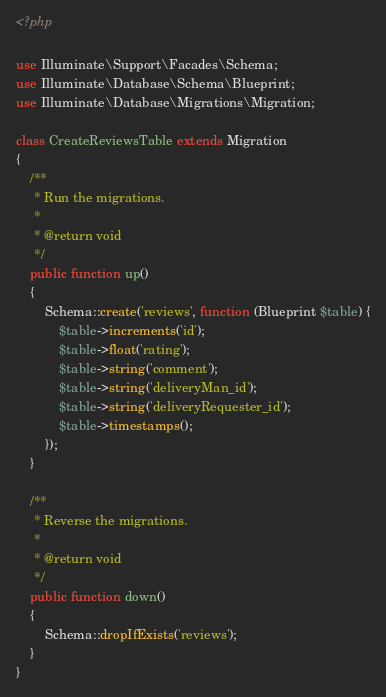Convert code to text. <code><loc_0><loc_0><loc_500><loc_500><_PHP_><?php

use Illuminate\Support\Facades\Schema;
use Illuminate\Database\Schema\Blueprint;
use Illuminate\Database\Migrations\Migration;

class CreateReviewsTable extends Migration
{
    /**
     * Run the migrations.
     *
     * @return void
     */
    public function up()
    {
        Schema::create('reviews', function (Blueprint $table) {
            $table->increments('id');
            $table->float('rating');
            $table->string('comment');
            $table->string('deliveryMan_id');
            $table->string('deliveryRequester_id');
            $table->timestamps();
        });
    }

    /**
     * Reverse the migrations.
     *
     * @return void
     */
    public function down()
    {
        Schema::dropIfExists('reviews');
    }
}
</code> 